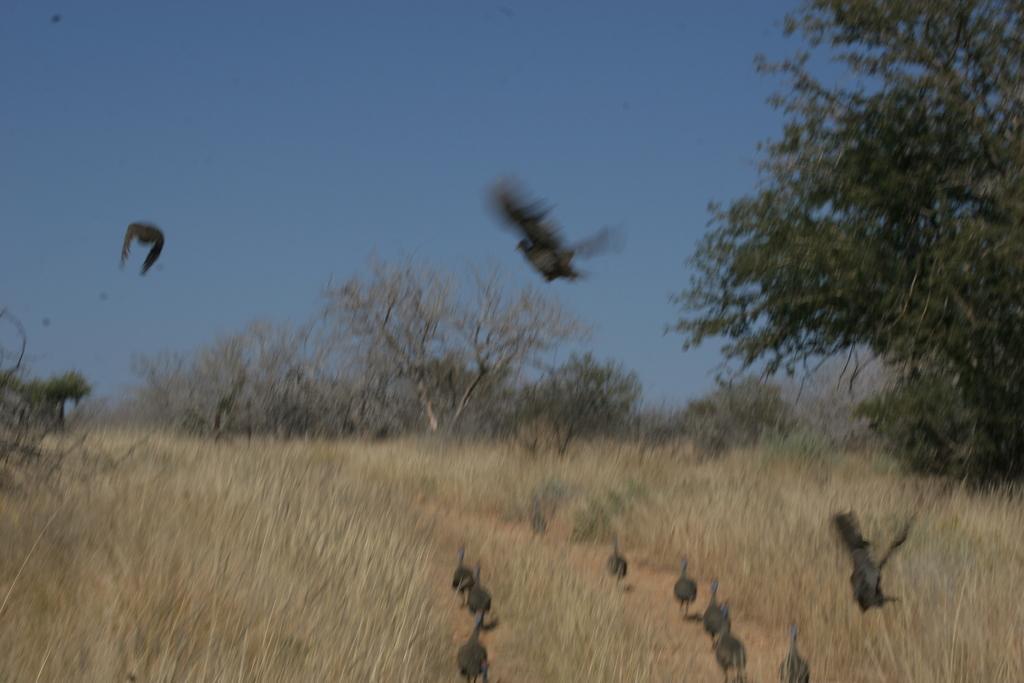Describe this image in one or two sentences. In this image I can see the grass. I can see the birds. In the background, I can see the trees and the sky. 